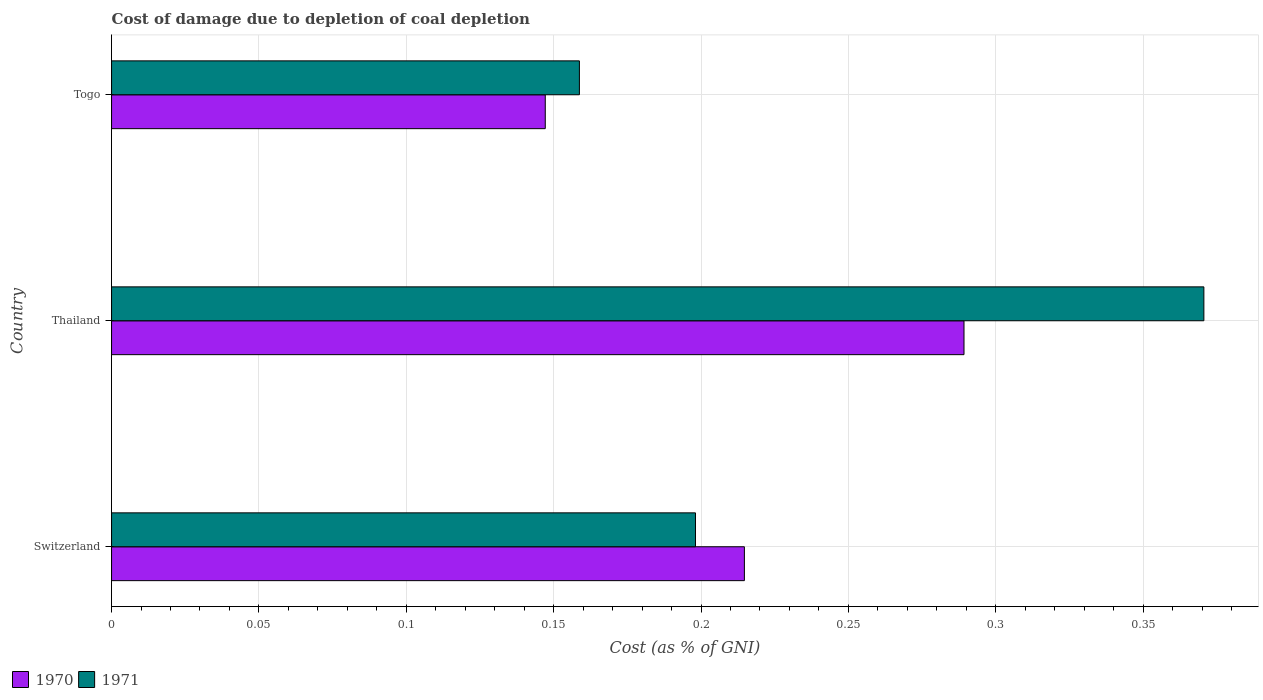Are the number of bars on each tick of the Y-axis equal?
Make the answer very short. Yes. How many bars are there on the 1st tick from the top?
Provide a succinct answer. 2. What is the label of the 1st group of bars from the top?
Offer a terse response. Togo. In how many cases, is the number of bars for a given country not equal to the number of legend labels?
Your answer should be very brief. 0. What is the cost of damage caused due to coal depletion in 1970 in Switzerland?
Offer a very short reply. 0.21. Across all countries, what is the maximum cost of damage caused due to coal depletion in 1971?
Your answer should be very brief. 0.37. Across all countries, what is the minimum cost of damage caused due to coal depletion in 1970?
Ensure brevity in your answer.  0.15. In which country was the cost of damage caused due to coal depletion in 1970 maximum?
Offer a terse response. Thailand. In which country was the cost of damage caused due to coal depletion in 1970 minimum?
Provide a short and direct response. Togo. What is the total cost of damage caused due to coal depletion in 1970 in the graph?
Make the answer very short. 0.65. What is the difference between the cost of damage caused due to coal depletion in 1970 in Switzerland and that in Thailand?
Your answer should be very brief. -0.07. What is the difference between the cost of damage caused due to coal depletion in 1971 in Switzerland and the cost of damage caused due to coal depletion in 1970 in Thailand?
Your answer should be very brief. -0.09. What is the average cost of damage caused due to coal depletion in 1971 per country?
Offer a terse response. 0.24. What is the difference between the cost of damage caused due to coal depletion in 1971 and cost of damage caused due to coal depletion in 1970 in Togo?
Your response must be concise. 0.01. In how many countries, is the cost of damage caused due to coal depletion in 1970 greater than 0.12000000000000001 %?
Keep it short and to the point. 3. What is the ratio of the cost of damage caused due to coal depletion in 1971 in Switzerland to that in Togo?
Keep it short and to the point. 1.25. Is the cost of damage caused due to coal depletion in 1971 in Switzerland less than that in Togo?
Ensure brevity in your answer.  No. What is the difference between the highest and the second highest cost of damage caused due to coal depletion in 1970?
Offer a very short reply. 0.07. What is the difference between the highest and the lowest cost of damage caused due to coal depletion in 1971?
Ensure brevity in your answer.  0.21. Is the sum of the cost of damage caused due to coal depletion in 1971 in Switzerland and Thailand greater than the maximum cost of damage caused due to coal depletion in 1970 across all countries?
Provide a succinct answer. Yes. What does the 2nd bar from the bottom in Thailand represents?
Provide a short and direct response. 1971. How many bars are there?
Keep it short and to the point. 6. How many countries are there in the graph?
Ensure brevity in your answer.  3. What is the difference between two consecutive major ticks on the X-axis?
Make the answer very short. 0.05. Are the values on the major ticks of X-axis written in scientific E-notation?
Provide a short and direct response. No. Does the graph contain grids?
Provide a succinct answer. Yes. How are the legend labels stacked?
Your answer should be compact. Horizontal. What is the title of the graph?
Provide a succinct answer. Cost of damage due to depletion of coal depletion. What is the label or title of the X-axis?
Provide a short and direct response. Cost (as % of GNI). What is the label or title of the Y-axis?
Your response must be concise. Country. What is the Cost (as % of GNI) in 1970 in Switzerland?
Your answer should be compact. 0.21. What is the Cost (as % of GNI) in 1971 in Switzerland?
Offer a very short reply. 0.2. What is the Cost (as % of GNI) of 1970 in Thailand?
Offer a very short reply. 0.29. What is the Cost (as % of GNI) of 1971 in Thailand?
Your answer should be compact. 0.37. What is the Cost (as % of GNI) of 1970 in Togo?
Keep it short and to the point. 0.15. What is the Cost (as % of GNI) of 1971 in Togo?
Keep it short and to the point. 0.16. Across all countries, what is the maximum Cost (as % of GNI) of 1970?
Ensure brevity in your answer.  0.29. Across all countries, what is the maximum Cost (as % of GNI) in 1971?
Your response must be concise. 0.37. Across all countries, what is the minimum Cost (as % of GNI) in 1970?
Make the answer very short. 0.15. Across all countries, what is the minimum Cost (as % of GNI) in 1971?
Offer a very short reply. 0.16. What is the total Cost (as % of GNI) of 1970 in the graph?
Your answer should be compact. 0.65. What is the total Cost (as % of GNI) of 1971 in the graph?
Provide a succinct answer. 0.73. What is the difference between the Cost (as % of GNI) in 1970 in Switzerland and that in Thailand?
Offer a terse response. -0.07. What is the difference between the Cost (as % of GNI) in 1971 in Switzerland and that in Thailand?
Provide a short and direct response. -0.17. What is the difference between the Cost (as % of GNI) of 1970 in Switzerland and that in Togo?
Keep it short and to the point. 0.07. What is the difference between the Cost (as % of GNI) in 1971 in Switzerland and that in Togo?
Make the answer very short. 0.04. What is the difference between the Cost (as % of GNI) of 1970 in Thailand and that in Togo?
Make the answer very short. 0.14. What is the difference between the Cost (as % of GNI) of 1971 in Thailand and that in Togo?
Offer a very short reply. 0.21. What is the difference between the Cost (as % of GNI) of 1970 in Switzerland and the Cost (as % of GNI) of 1971 in Thailand?
Your answer should be very brief. -0.16. What is the difference between the Cost (as % of GNI) in 1970 in Switzerland and the Cost (as % of GNI) in 1971 in Togo?
Offer a terse response. 0.06. What is the difference between the Cost (as % of GNI) in 1970 in Thailand and the Cost (as % of GNI) in 1971 in Togo?
Offer a terse response. 0.13. What is the average Cost (as % of GNI) of 1970 per country?
Offer a very short reply. 0.22. What is the average Cost (as % of GNI) in 1971 per country?
Give a very brief answer. 0.24. What is the difference between the Cost (as % of GNI) in 1970 and Cost (as % of GNI) in 1971 in Switzerland?
Your answer should be very brief. 0.02. What is the difference between the Cost (as % of GNI) in 1970 and Cost (as % of GNI) in 1971 in Thailand?
Keep it short and to the point. -0.08. What is the difference between the Cost (as % of GNI) in 1970 and Cost (as % of GNI) in 1971 in Togo?
Ensure brevity in your answer.  -0.01. What is the ratio of the Cost (as % of GNI) of 1970 in Switzerland to that in Thailand?
Your answer should be very brief. 0.74. What is the ratio of the Cost (as % of GNI) of 1971 in Switzerland to that in Thailand?
Your answer should be compact. 0.53. What is the ratio of the Cost (as % of GNI) in 1970 in Switzerland to that in Togo?
Your answer should be compact. 1.46. What is the ratio of the Cost (as % of GNI) of 1971 in Switzerland to that in Togo?
Offer a terse response. 1.25. What is the ratio of the Cost (as % of GNI) in 1970 in Thailand to that in Togo?
Offer a very short reply. 1.97. What is the ratio of the Cost (as % of GNI) in 1971 in Thailand to that in Togo?
Your response must be concise. 2.33. What is the difference between the highest and the second highest Cost (as % of GNI) of 1970?
Ensure brevity in your answer.  0.07. What is the difference between the highest and the second highest Cost (as % of GNI) of 1971?
Provide a succinct answer. 0.17. What is the difference between the highest and the lowest Cost (as % of GNI) in 1970?
Ensure brevity in your answer.  0.14. What is the difference between the highest and the lowest Cost (as % of GNI) in 1971?
Your answer should be very brief. 0.21. 